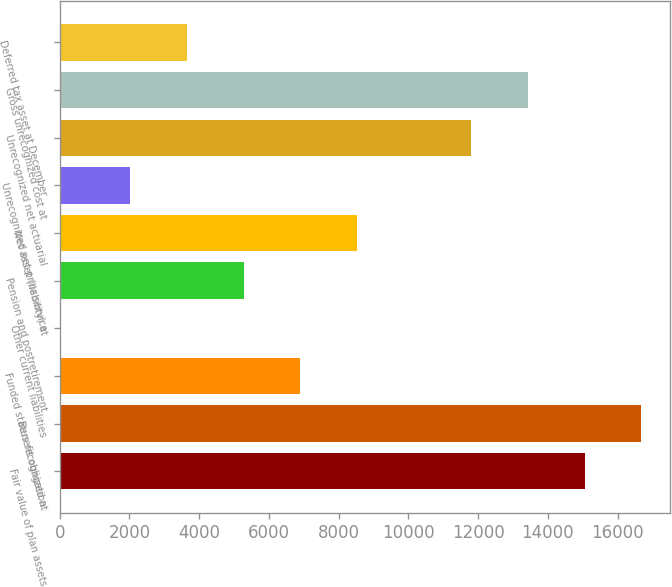<chart> <loc_0><loc_0><loc_500><loc_500><bar_chart><fcel>Fair value of plan assets<fcel>Benefit obligation<fcel>Funded status recognized at<fcel>Other current liabilities<fcel>Pension and postretirement<fcel>Net asset (liability) at<fcel>Unrecognized net prior service<fcel>Unrecognized net actuarial<fcel>Gross unrecognized cost at<fcel>Deferred tax asset at December<nl><fcel>15051.4<fcel>16680.7<fcel>6904.9<fcel>10<fcel>5275.6<fcel>8534.2<fcel>2017<fcel>11792.8<fcel>13422.1<fcel>3646.3<nl></chart> 